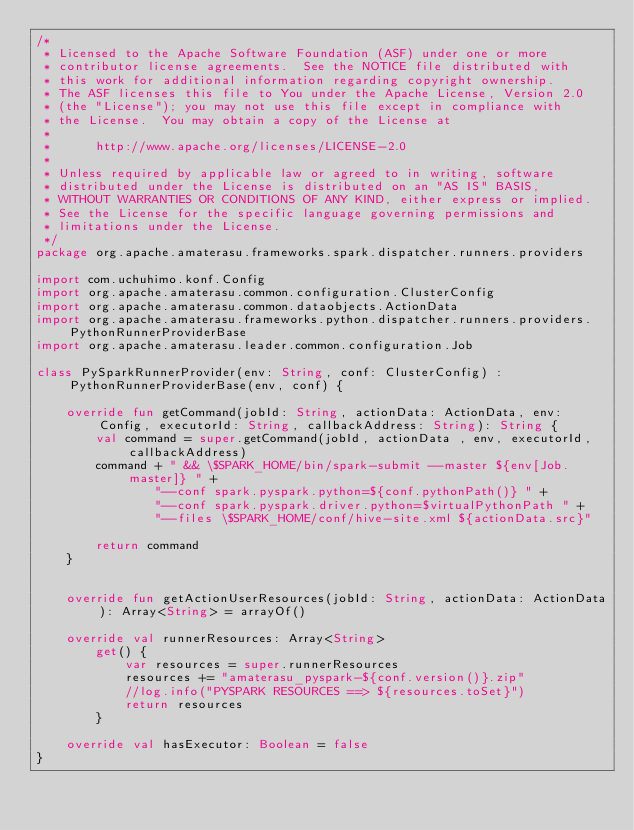<code> <loc_0><loc_0><loc_500><loc_500><_Kotlin_>/*
 * Licensed to the Apache Software Foundation (ASF) under one or more
 * contributor license agreements.  See the NOTICE file distributed with
 * this work for additional information regarding copyright ownership.
 * The ASF licenses this file to You under the Apache License, Version 2.0
 * (the "License"); you may not use this file except in compliance with
 * the License.  You may obtain a copy of the License at
 *
 *      http://www.apache.org/licenses/LICENSE-2.0
 *
 * Unless required by applicable law or agreed to in writing, software
 * distributed under the License is distributed on an "AS IS" BASIS,
 * WITHOUT WARRANTIES OR CONDITIONS OF ANY KIND, either express or implied.
 * See the License for the specific language governing permissions and
 * limitations under the License.
 */
package org.apache.amaterasu.frameworks.spark.dispatcher.runners.providers

import com.uchuhimo.konf.Config
import org.apache.amaterasu.common.configuration.ClusterConfig
import org.apache.amaterasu.common.dataobjects.ActionData
import org.apache.amaterasu.frameworks.python.dispatcher.runners.providers.PythonRunnerProviderBase
import org.apache.amaterasu.leader.common.configuration.Job

class PySparkRunnerProvider(env: String, conf: ClusterConfig) : PythonRunnerProviderBase(env, conf) {

    override fun getCommand(jobId: String, actionData: ActionData, env: Config, executorId: String, callbackAddress: String): String {
        val command = super.getCommand(jobId, actionData , env, executorId, callbackAddress)
        command + " && \$SPARK_HOME/bin/spark-submit --master ${env[Job.master]} " +
                "--conf spark.pyspark.python=${conf.pythonPath()} " +
                "--conf spark.pyspark.driver.python=$virtualPythonPath " +
                "--files \$SPARK_HOME/conf/hive-site.xml ${actionData.src}"

        return command
    }


    override fun getActionUserResources(jobId: String, actionData: ActionData): Array<String> = arrayOf()

    override val runnerResources: Array<String>
        get() {
            var resources = super.runnerResources
            resources += "amaterasu_pyspark-${conf.version()}.zip"
            //log.info("PYSPARK RESOURCES ==> ${resources.toSet}")
            return resources
        }

    override val hasExecutor: Boolean = false
}</code> 